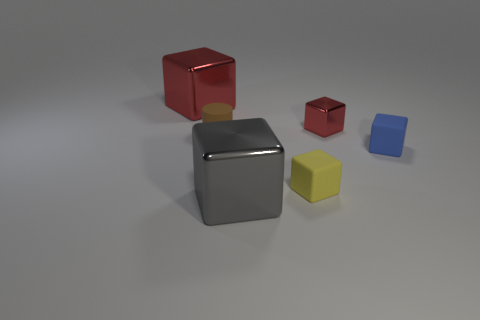Subtract 2 cubes. How many cubes are left? 3 Subtract all yellow blocks. How many blocks are left? 4 Subtract all small blue matte cubes. How many cubes are left? 4 Subtract all red blocks. Subtract all gray spheres. How many blocks are left? 3 Add 1 big purple spheres. How many objects exist? 7 Subtract all blocks. How many objects are left? 1 Add 3 tiny rubber things. How many tiny rubber things exist? 6 Subtract 0 brown balls. How many objects are left? 6 Subtract all small blue rubber cylinders. Subtract all blue cubes. How many objects are left? 5 Add 3 tiny yellow rubber objects. How many tiny yellow rubber objects are left? 4 